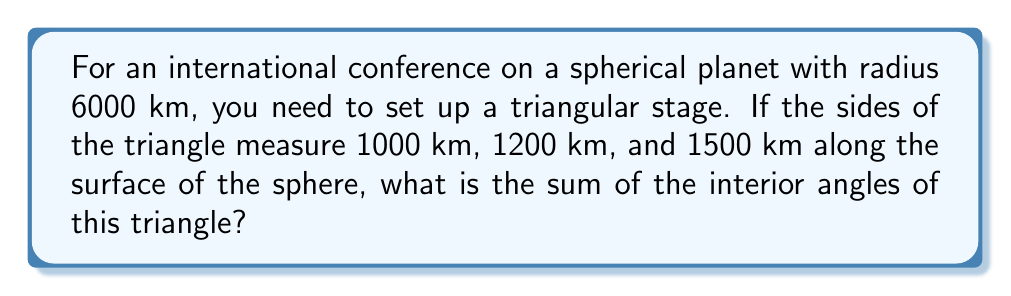What is the answer to this math problem? To solve this problem, we'll use the formula for the area of a spherical triangle and relate it to the angle sum. Here's the step-by-step solution:

1) In spherical geometry, the area $A$ of a triangle is related to its angle sum $\alpha + \beta + \gamma$ and the radius $R$ of the sphere by the formula:

   $$A = R^2(\alpha + \beta + \gamma - \pi)$$

2) We need to find the area of the triangle using Girard's Theorem. First, calculate the semi-perimeter $s$:

   $$s = \frac{a + b + c}{2} = \frac{1000 + 1200 + 1500}{2} = 1850 \text{ km}$$

3) Now use Girard's formula for the area of a spherical triangle:

   $$A = 4R^2 \arctan(\sqrt{\tan(\frac{s}{2R})\tan(\frac{s-a}{2R})\tan(\frac{s-b}{2R})\tan(\frac{s-c}{2R})})$$

4) Substitute the values:
   $R = 6000 \text{ km}$
   $s = 1850 \text{ km}$
   $a = 1000 \text{ km}$
   $b = 1200 \text{ km}$
   $c = 1500 \text{ km}$

5) Calculate:

   $$A = 4(6000)^2 \arctan(\sqrt{\tan(\frac{1850}{12000})\tan(\frac{850}{12000})\tan(\frac{650}{12000})\tan(\frac{350}{12000})})$$

6) This gives us $A \approx 20,944,625 \text{ km}^2$

7) Now we can use the first equation to solve for the angle sum:

   $$20,944,625 = 6000^2(\alpha + \beta + \gamma - \pi)$$

8) Solving for $(\alpha + \beta + \gamma)$:

   $$\alpha + \beta + \gamma = \frac{20,944,625}{36,000,000} + \pi \approx 3.7516 \text{ radians}$$

9) Convert to degrees:

   $$3.7516 \text{ radians} \times \frac{180°}{\pi} \approx 214.96°$$
Answer: $214.96°$ 